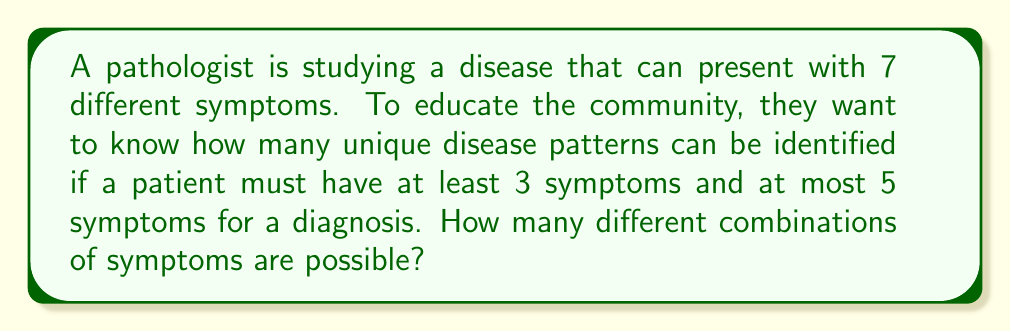What is the answer to this math problem? Let's approach this step-by-step:

1) We need to find the number of combinations with 3, 4, or 5 symptoms out of 7 total symptoms.

2) For each case, we can use the combination formula:

   $C(n,r) = \binom{n}{r} = \frac{n!}{r!(n-r)!}$

   where n is the total number of symptoms (7) and r is the number of symptoms we're selecting.

3) For 3 symptoms: $C(7,3) = \binom{7}{3} = \frac{7!}{3!(7-3)!} = \frac{7!}{3!4!} = 35$

4) For 4 symptoms: $C(7,4) = \binom{7}{4} = \frac{7!}{4!(7-4)!} = \frac{7!}{4!3!} = 35$

5) For 5 symptoms: $C(7,5) = \binom{7}{5} = \frac{7!}{5!(7-5)!} = \frac{7!}{5!2!} = 21$

6) The total number of possible combinations is the sum of these:

   $35 + 35 + 21 = 91$

Therefore, there are 91 different possible combinations of symptoms that could indicate the disease.
Answer: 91 